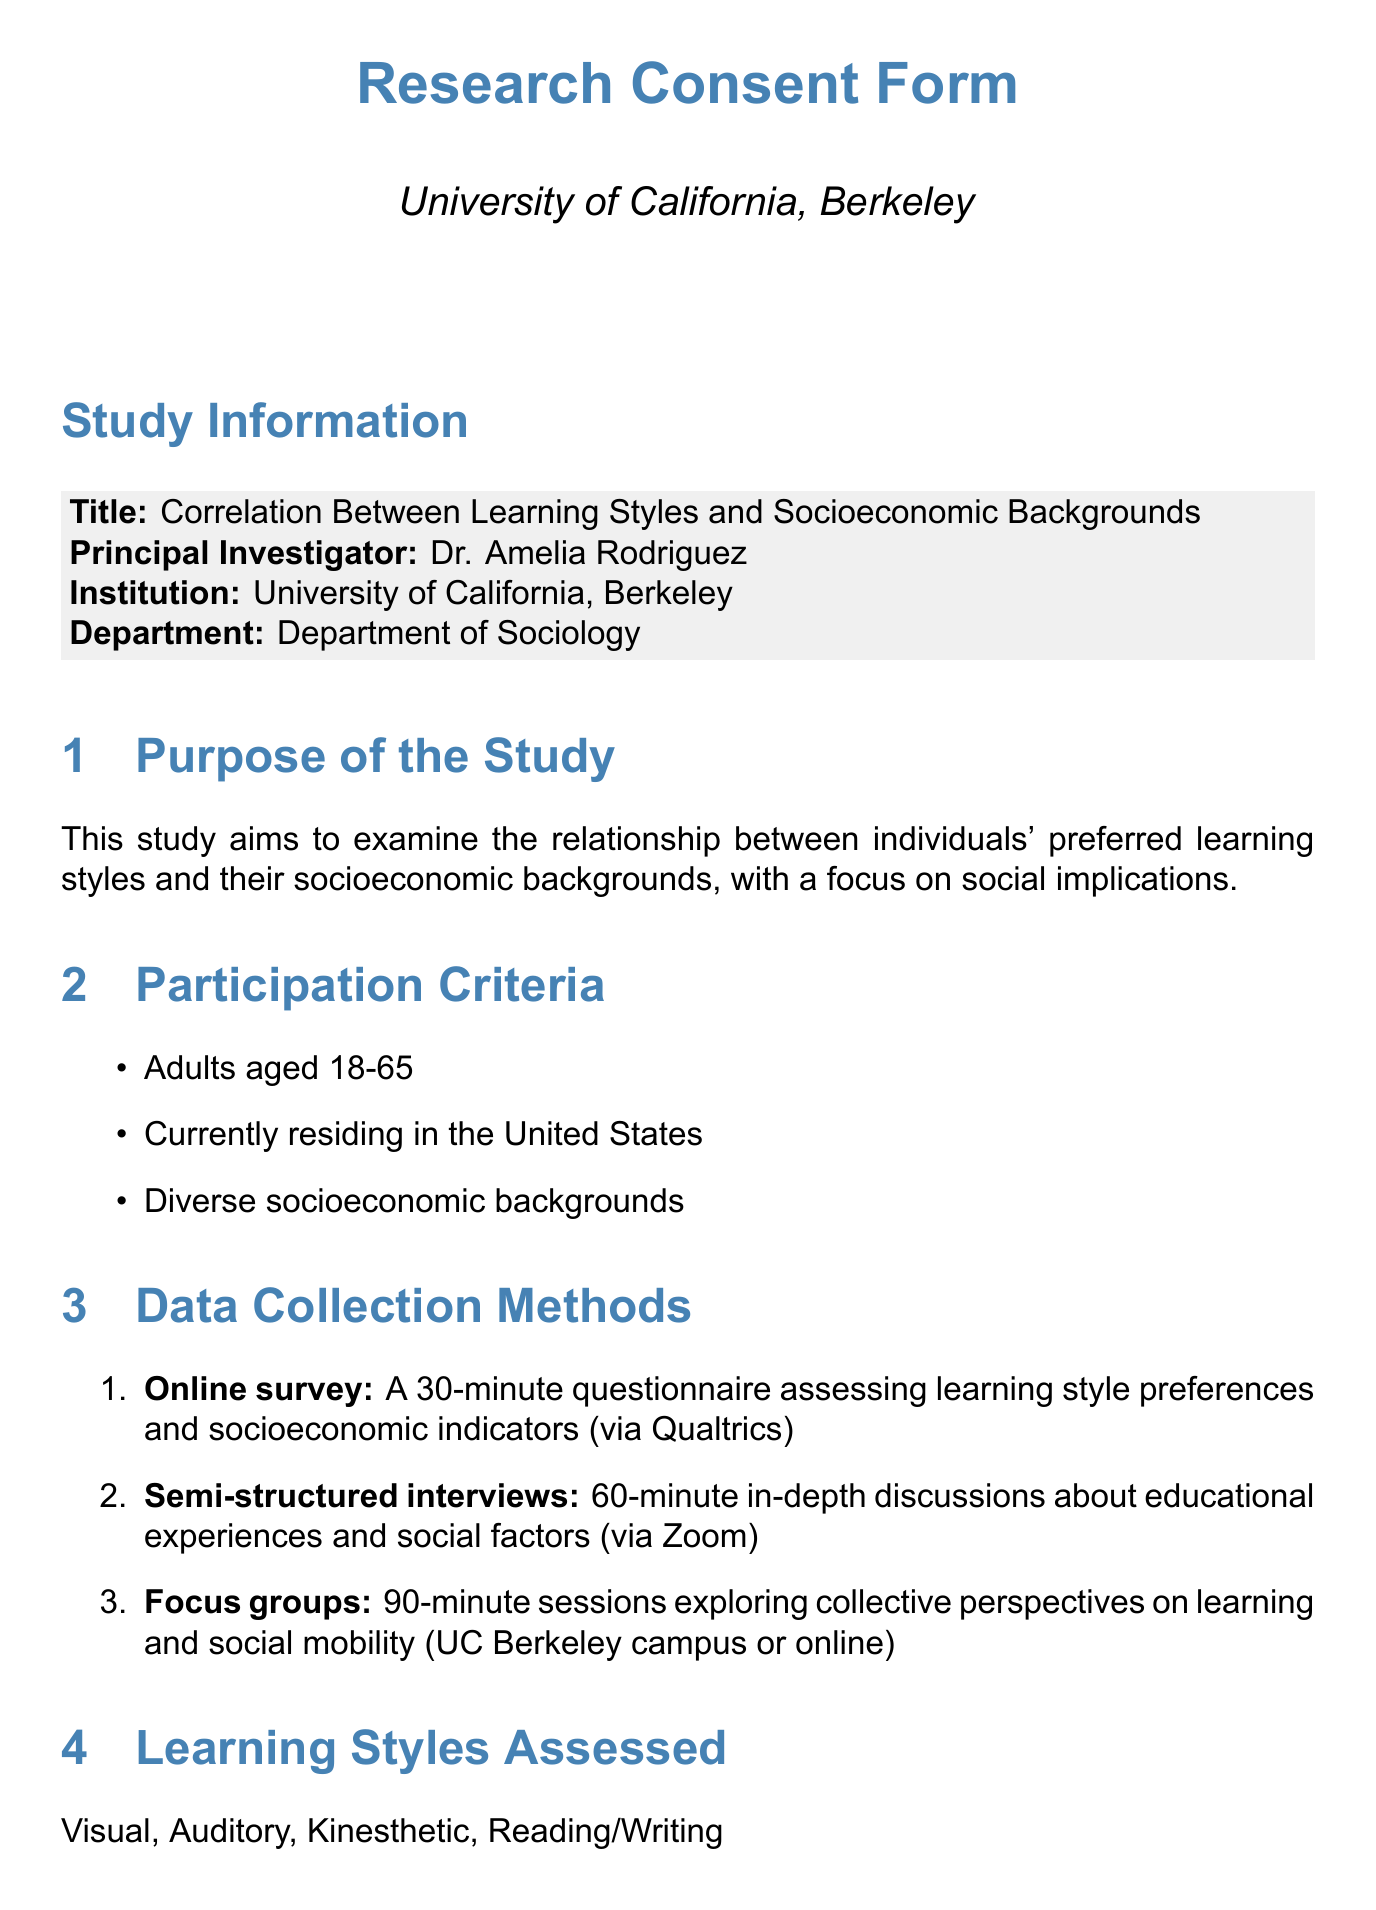What is the title of the study? The title of the study is explicitly mentioned in the document's study information section.
Answer: Correlation Between Learning Styles and Socioeconomic Backgrounds Who is the principal investigator? The principal investigator's name is listed in the study information section.
Answer: Dr. Amelia Rodriguez What is the duration of the online survey? The duration of the online survey is specified in the data collection methods section.
Answer: 30 minutes What are the socioeconomic factors considered in the study? The document lists specific socioeconomic factors in the relevant section, which highlights the focus of the research.
Answer: Income level, Parental education, Occupation, Neighborhood characteristics, Access to educational resources What type of data collection method involves 60-minute discussions? The document outlines this method in the data collection methods section.
Answer: Semi-structured interviews Is participation in this study voluntary? A statement about the nature of participation is included in the document.
Answer: Yes What compensation is offered to focus group participants? The compensation details are clearly stated in the relevant section of the document.
Answer: $50 Amazon gift card What measures are taken to protect data? The document provides a list of protective measures within the data protection measures section.
Answer: Encryption of all digital data What is the purpose of the study? The purpose of the study is clearly articulated in the document's purpose section.
Answer: To examine the relationship between individuals' preferred learning styles and their socioeconomic backgrounds, with a focus on social implications 